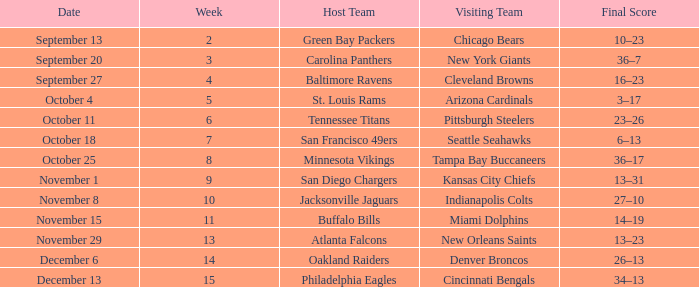What team played on the road against the Buffalo Bills at home ? Miami Dolphins. Help me parse the entirety of this table. {'header': ['Date', 'Week', 'Host Team', 'Visiting Team', 'Final Score'], 'rows': [['September 13', '2', 'Green Bay Packers', 'Chicago Bears', '10–23'], ['September 20', '3', 'Carolina Panthers', 'New York Giants', '36–7'], ['September 27', '4', 'Baltimore Ravens', 'Cleveland Browns', '16–23'], ['October 4', '5', 'St. Louis Rams', 'Arizona Cardinals', '3–17'], ['October 11', '6', 'Tennessee Titans', 'Pittsburgh Steelers', '23–26'], ['October 18', '7', 'San Francisco 49ers', 'Seattle Seahawks', '6–13'], ['October 25', '8', 'Minnesota Vikings', 'Tampa Bay Buccaneers', '36–17'], ['November 1', '9', 'San Diego Chargers', 'Kansas City Chiefs', '13–31'], ['November 8', '10', 'Jacksonville Jaguars', 'Indianapolis Colts', '27–10'], ['November 15', '11', 'Buffalo Bills', 'Miami Dolphins', '14–19'], ['November 29', '13', 'Atlanta Falcons', 'New Orleans Saints', '13–23'], ['December 6', '14', 'Oakland Raiders', 'Denver Broncos', '26–13'], ['December 13', '15', 'Philadelphia Eagles', 'Cincinnati Bengals', '34–13']]} 